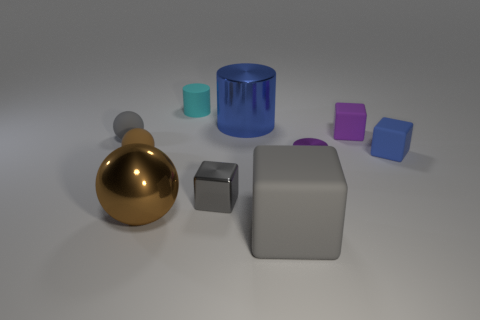Is there anything else of the same color as the large matte cube?
Give a very brief answer. Yes. Are there fewer blocks left of the large brown object than large blue shiny things?
Ensure brevity in your answer.  Yes. Are there more yellow cubes than gray matte balls?
Provide a short and direct response. No. There is a cylinder on the left side of the big object that is behind the tiny blue matte block; is there a tiny cyan matte thing that is in front of it?
Keep it short and to the point. No. What number of other objects are the same size as the gray ball?
Keep it short and to the point. 6. There is a large brown metal sphere; are there any big brown balls to the right of it?
Offer a very short reply. No. Do the shiny block and the thing that is to the left of the tiny brown rubber sphere have the same color?
Your answer should be compact. Yes. There is a large metal thing that is on the right side of the tiny cyan rubber cylinder that is behind the gray thing that is on the left side of the brown matte sphere; what color is it?
Provide a succinct answer. Blue. Is there a yellow metal object that has the same shape as the tiny purple rubber thing?
Your response must be concise. No. There is a metal cylinder that is the same size as the gray ball; what color is it?
Provide a short and direct response. Purple. 